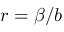Convert formula to latex. <formula><loc_0><loc_0><loc_500><loc_500>r = \beta / b</formula> 